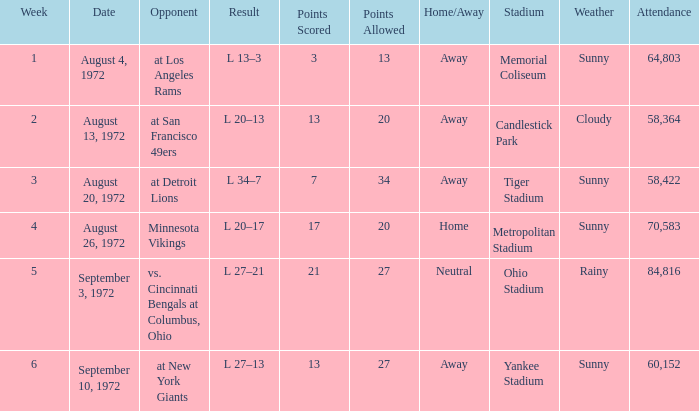What is the lowest attendance on September 3, 1972? 84816.0. 